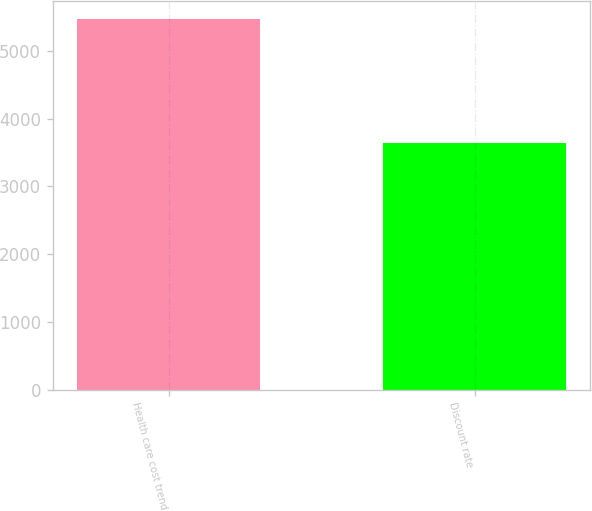<chart> <loc_0><loc_0><loc_500><loc_500><bar_chart><fcel>Health care cost trend<fcel>Discount rate<nl><fcel>5471<fcel>3649<nl></chart> 